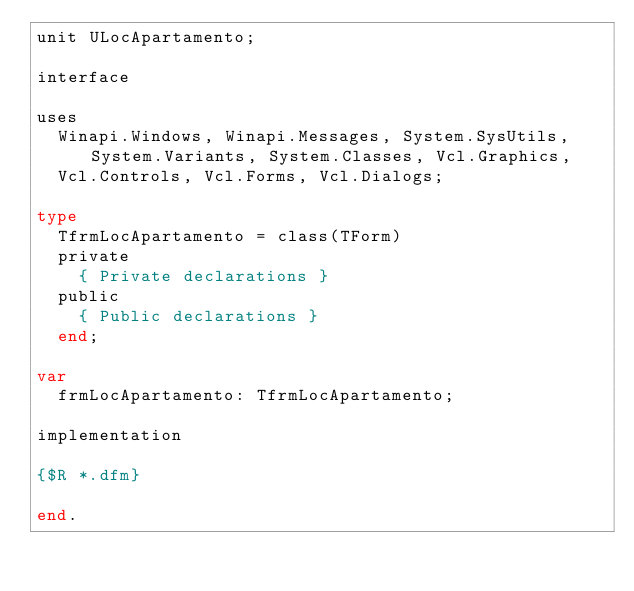Convert code to text. <code><loc_0><loc_0><loc_500><loc_500><_Pascal_>unit ULocApartamento;

interface

uses
  Winapi.Windows, Winapi.Messages, System.SysUtils, System.Variants, System.Classes, Vcl.Graphics,
  Vcl.Controls, Vcl.Forms, Vcl.Dialogs;

type
  TfrmLocApartamento = class(TForm)
  private
    { Private declarations }
  public
    { Public declarations }
  end;

var
  frmLocApartamento: TfrmLocApartamento;

implementation

{$R *.dfm}

end.
</code> 